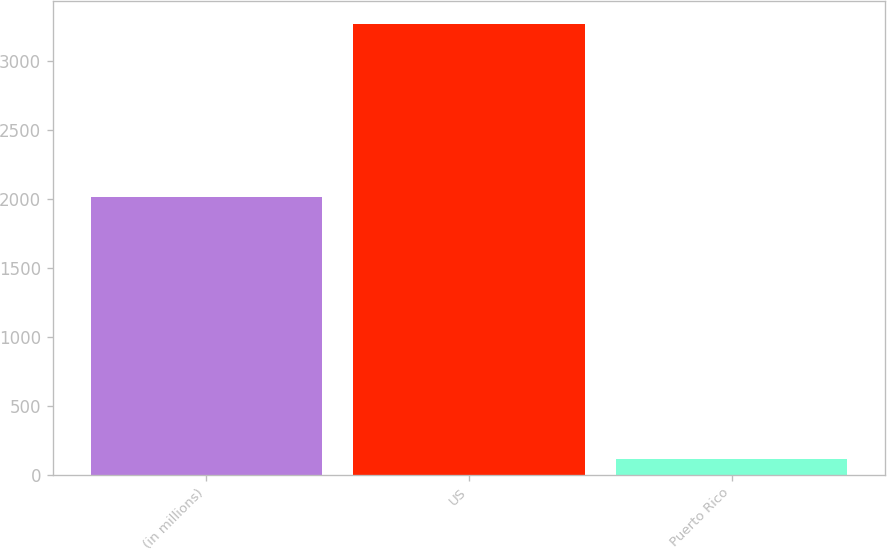Convert chart. <chart><loc_0><loc_0><loc_500><loc_500><bar_chart><fcel>(in millions)<fcel>US<fcel>Puerto Rico<nl><fcel>2017<fcel>3274<fcel>113<nl></chart> 